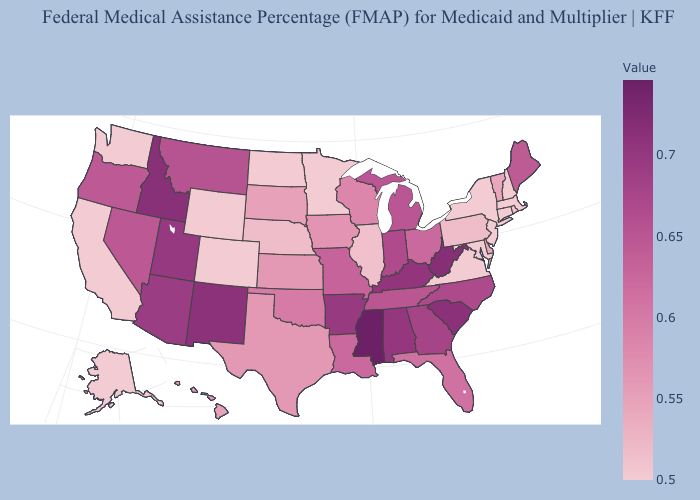Does Mississippi have the highest value in the USA?
Answer briefly. Yes. Does Minnesota have the lowest value in the MidWest?
Write a very short answer. Yes. Among the states that border Tennessee , does Mississippi have the highest value?
Keep it brief. Yes. Does Arkansas have the lowest value in the USA?
Give a very brief answer. No. Which states have the lowest value in the USA?
Write a very short answer. Alaska, California, Connecticut, Maryland, Massachusetts, Minnesota, New Hampshire, New Jersey, New York, North Dakota, Virginia, Washington, Wyoming. Among the states that border North Dakota , does Minnesota have the lowest value?
Concise answer only. Yes. Which states have the highest value in the USA?
Keep it brief. Mississippi. Does Mississippi have the highest value in the USA?
Write a very short answer. Yes. 